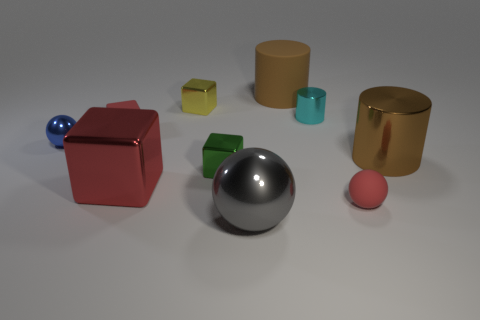What is the material of the ball behind the big brown cylinder to the right of the large matte thing?
Your answer should be very brief. Metal. Are there more big brown metallic cylinders that are on the right side of the blue metallic ball than green objects?
Give a very brief answer. No. What number of other objects are the same size as the blue thing?
Give a very brief answer. 5. Does the tiny shiny cylinder have the same color as the matte cube?
Your response must be concise. No. What is the color of the large cube to the left of the yellow block in front of the big cylinder behind the brown metallic cylinder?
Make the answer very short. Red. There is a metal cube behind the small blue metal thing that is behind the gray object; how many cyan things are behind it?
Your response must be concise. 0. Is there any other thing that is the same color as the large matte object?
Offer a very short reply. Yes. Do the sphere right of the gray sphere and the small shiny sphere have the same size?
Your response must be concise. Yes. What number of small blue balls are right of the large brown thing to the left of the brown metallic object?
Offer a very short reply. 0. There is a ball to the left of the red rubber thing to the left of the big gray metal ball; is there a tiny metallic thing that is behind it?
Your answer should be very brief. Yes. 